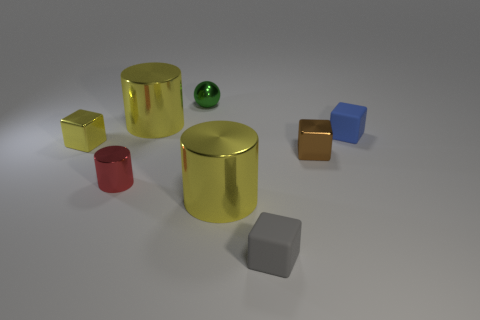Are there more matte cubes that are in front of the brown thing than small metallic things behind the green thing?
Provide a succinct answer. Yes. How many objects are large objects in front of the small red cylinder or large gray objects?
Make the answer very short. 1. What shape is the green thing that is the same material as the small red thing?
Offer a terse response. Sphere. Are there any other things that are the same shape as the small brown metallic object?
Your answer should be compact. Yes. What color is the tiny block that is both to the left of the small brown object and behind the small gray matte block?
Offer a terse response. Yellow. What number of balls are either tiny gray rubber things or large purple metallic things?
Ensure brevity in your answer.  0. What number of other rubber objects are the same size as the brown object?
Your answer should be very brief. 2. How many yellow cylinders are behind the metal cube that is behind the brown metal block?
Provide a succinct answer. 1. What size is the metal object that is left of the small green shiny thing and behind the yellow shiny block?
Ensure brevity in your answer.  Large. Is the number of tiny brown shiny objects greater than the number of green matte objects?
Offer a terse response. Yes. 